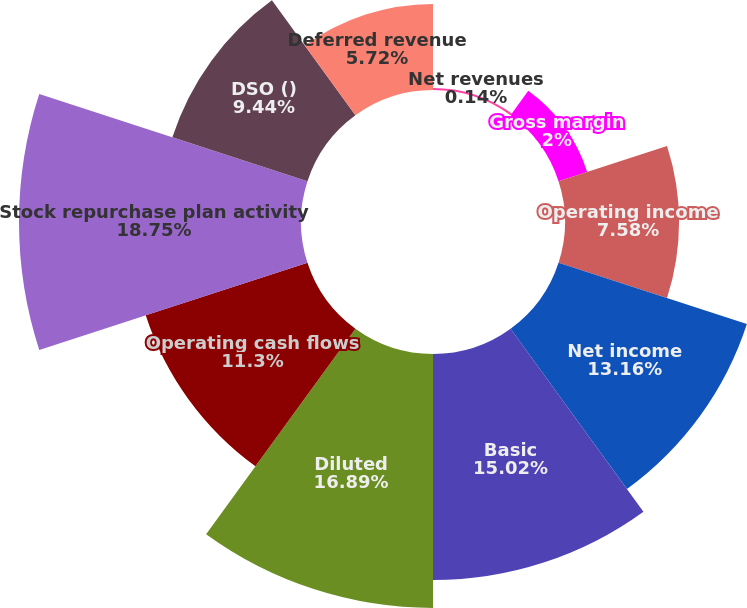<chart> <loc_0><loc_0><loc_500><loc_500><pie_chart><fcel>Net revenues<fcel>Gross margin<fcel>Operating income<fcel>Net income<fcel>Basic<fcel>Diluted<fcel>Operating cash flows<fcel>Stock repurchase plan activity<fcel>DSO ()<fcel>Deferred revenue<nl><fcel>0.14%<fcel>2.0%<fcel>7.58%<fcel>13.16%<fcel>15.02%<fcel>16.88%<fcel>11.3%<fcel>18.74%<fcel>9.44%<fcel>5.72%<nl></chart> 